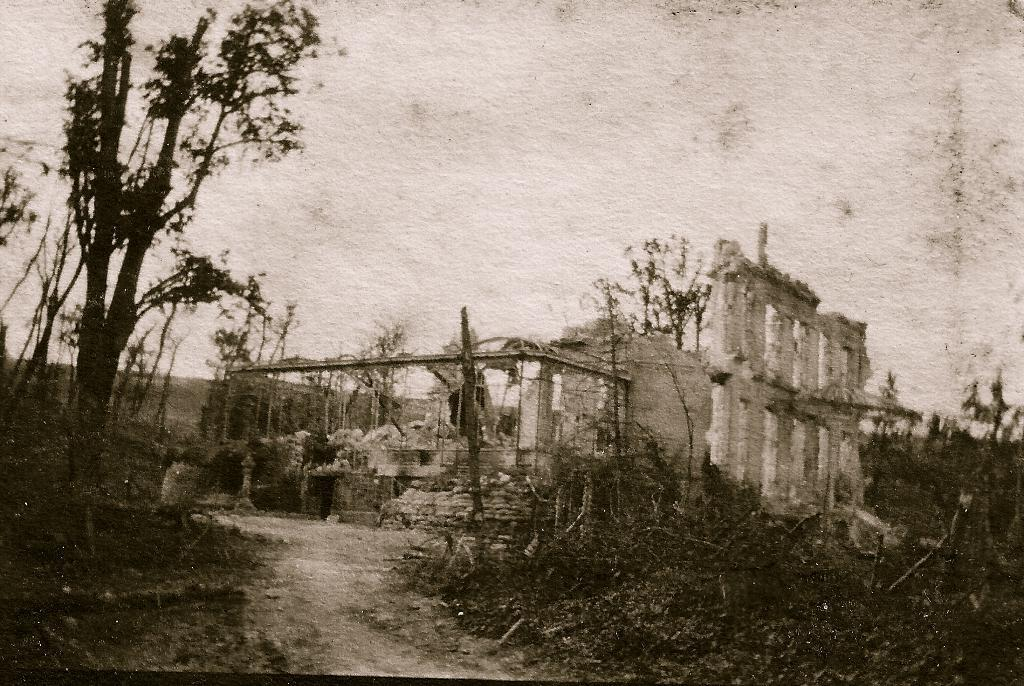What type of vegetation can be seen in the image? There are plants and trees in the image. What structure is depicted as damaged or destroyed in the image? There is a collapsed house in the image. What is visible in the background of the image? The sky is visible in the background of the image. Can you see the tiger's mouth in the image? There is no tiger present in the image, so its mouth cannot be seen. What type of linen is draped over the collapsed house in the image? There is no linen visible in the image, as it only features plants, trees, and a collapsed house. 